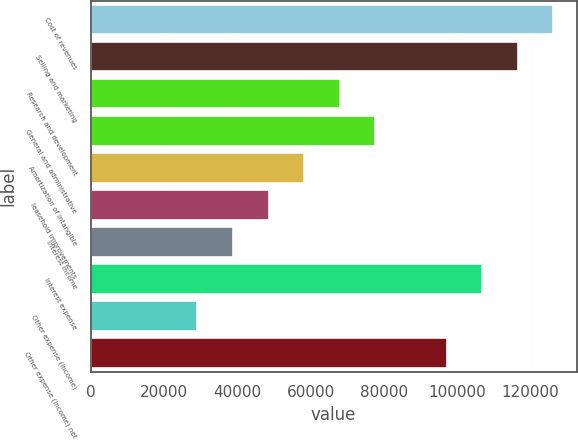Convert chart. <chart><loc_0><loc_0><loc_500><loc_500><bar_chart><fcel>Cost of revenues<fcel>Selling and marketing<fcel>Research and development<fcel>General and administrative<fcel>Amortization of intangible<fcel>leasehold improvements<fcel>Interest income<fcel>Interest expense<fcel>Other expense (income)<fcel>Other expense (income) net<nl><fcel>126223<fcel>116514<fcel>67966.7<fcel>77676.2<fcel>58257.3<fcel>48547.9<fcel>38838.4<fcel>106804<fcel>29129<fcel>97095<nl></chart> 